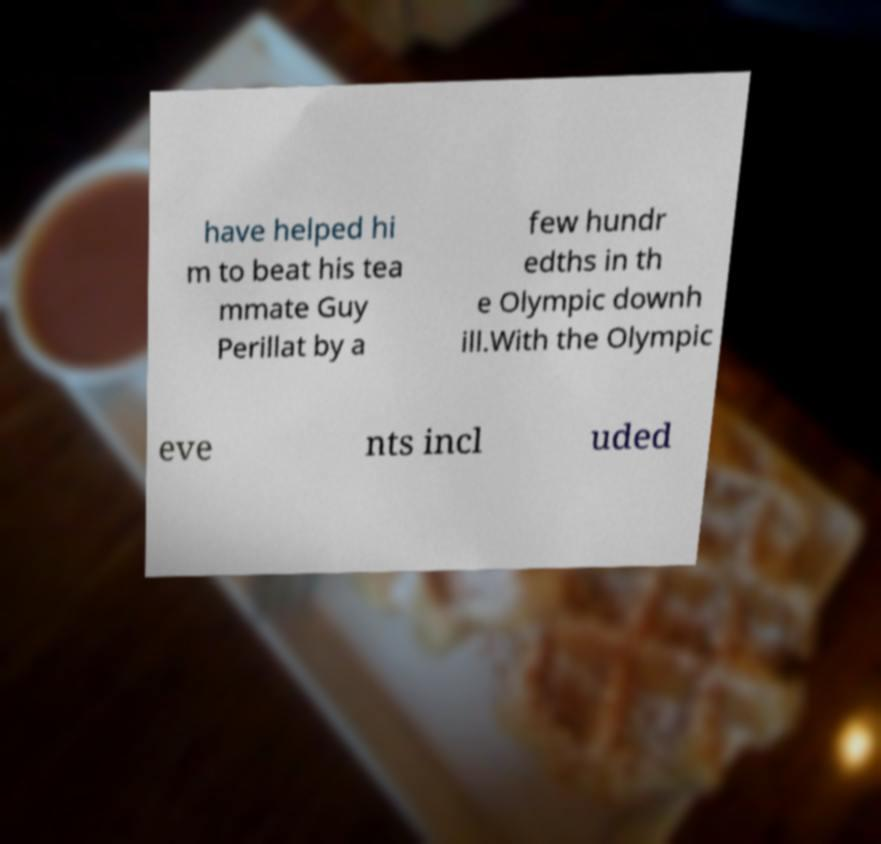Can you accurately transcribe the text from the provided image for me? have helped hi m to beat his tea mmate Guy Perillat by a few hundr edths in th e Olympic downh ill.With the Olympic eve nts incl uded 